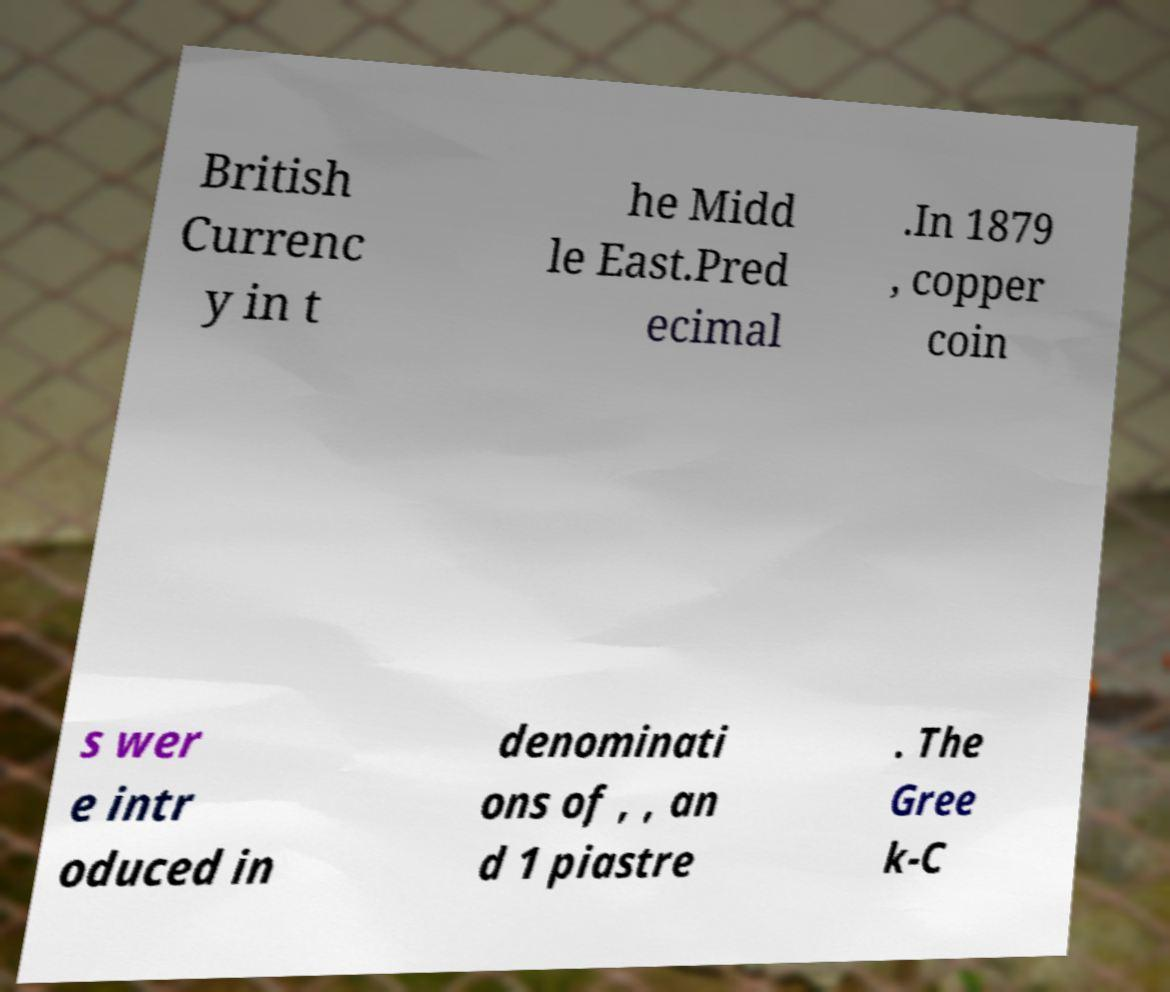There's text embedded in this image that I need extracted. Can you transcribe it verbatim? British Currenc y in t he Midd le East.Pred ecimal .In 1879 , copper coin s wer e intr oduced in denominati ons of , , an d 1 piastre . The Gree k-C 